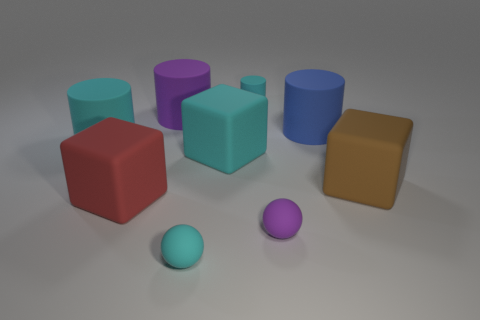Subtract all large purple cylinders. How many cylinders are left? 3 Subtract all purple balls. How many balls are left? 1 Subtract all cubes. How many objects are left? 6 Subtract all yellow blocks. How many cyan cylinders are left? 2 Add 2 large brown rubber objects. How many large brown rubber objects are left? 3 Add 8 tiny cyan rubber objects. How many tiny cyan rubber objects exist? 10 Subtract 1 purple balls. How many objects are left? 8 Subtract 2 spheres. How many spheres are left? 0 Subtract all purple blocks. Subtract all gray cylinders. How many blocks are left? 3 Subtract all purple things. Subtract all brown rubber objects. How many objects are left? 6 